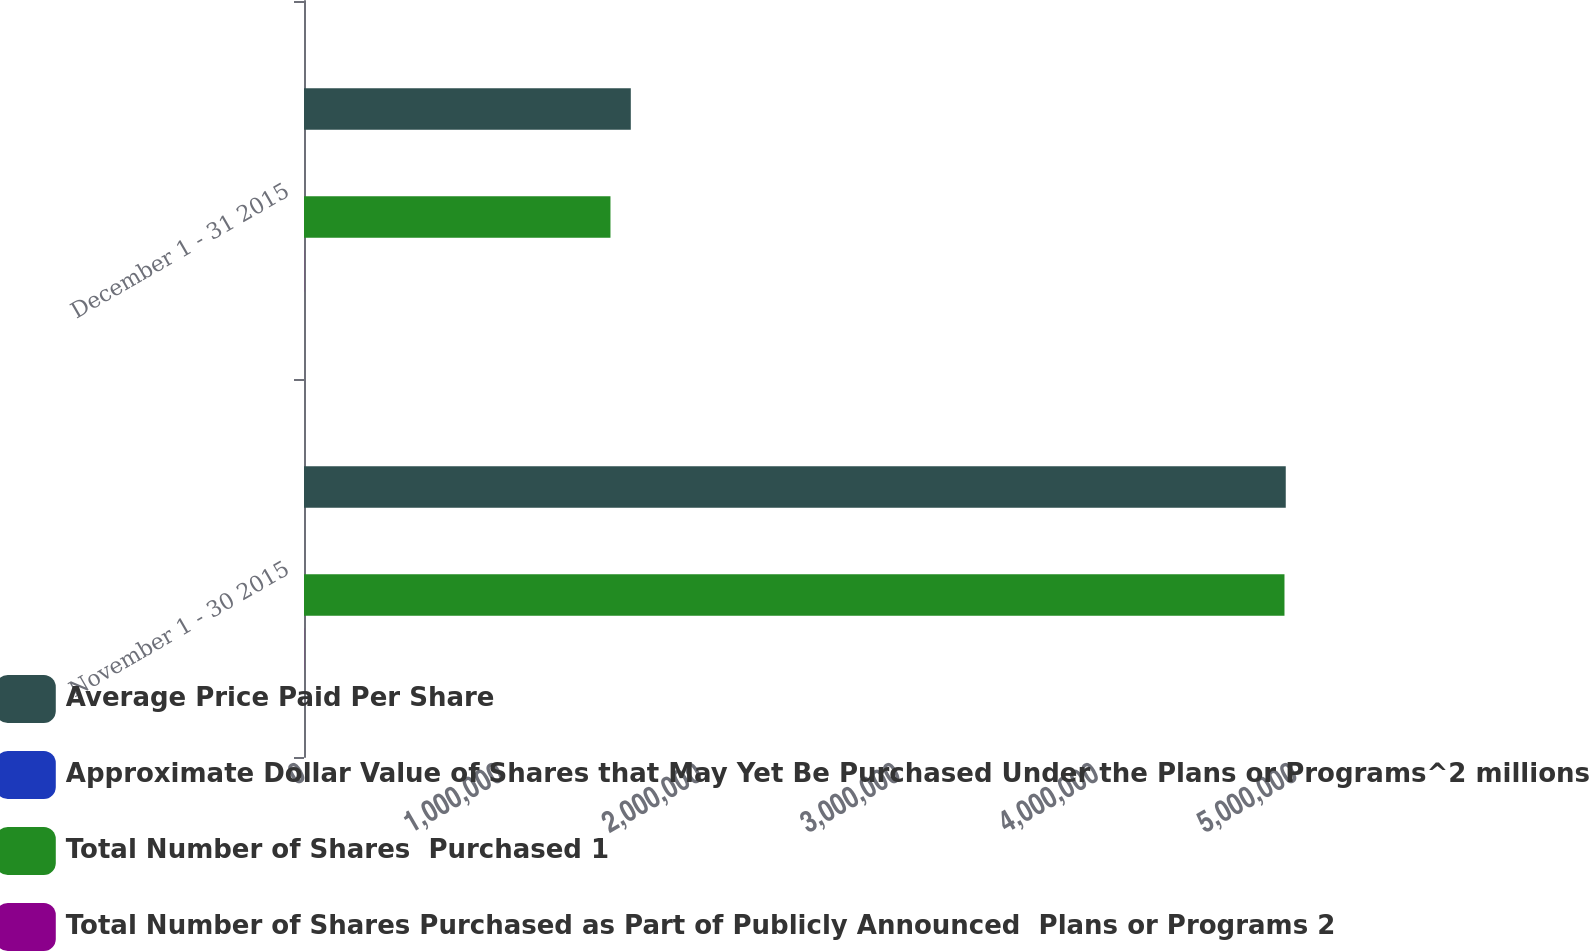Convert chart. <chart><loc_0><loc_0><loc_500><loc_500><stacked_bar_chart><ecel><fcel>November 1 - 30 2015<fcel>December 1 - 31 2015<nl><fcel>Average Price Paid Per Share<fcel>4.94839e+06<fcel>1.64719e+06<nl><fcel>Approximate Dollar Value of Shares that May Yet Be Purchased Under the Plans or Programs^2 millions<fcel>33.15<fcel>32.92<nl><fcel>Total Number of Shares  Purchased 1<fcel>4.94192e+06<fcel>1.54466e+06<nl><fcel>Total Number of Shares Purchased as Part of Publicly Announced  Plans or Programs 2<fcel>729<fcel>678<nl></chart> 